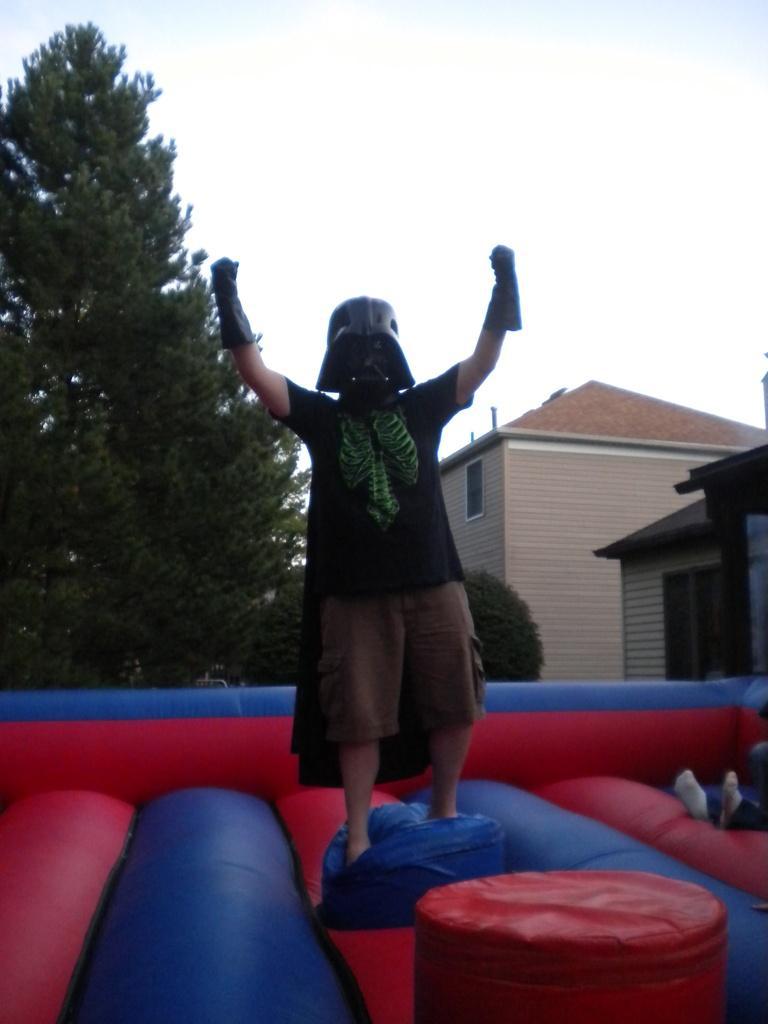Please provide a concise description of this image. This picture shows a man standing with a mask on his face and gloves to his hands and we see a jumping balloon and couple of trees on the back and couple of houses on the side and we see a cloudy sky. 